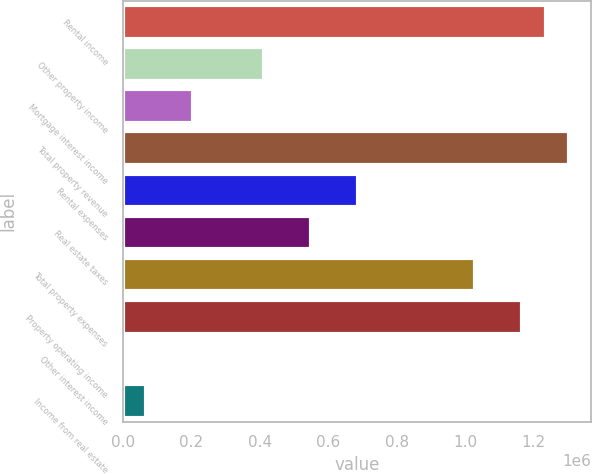Convert chart to OTSL. <chart><loc_0><loc_0><loc_500><loc_500><bar_chart><fcel>Rental income<fcel>Other property income<fcel>Mortgage interest income<fcel>Total property revenue<fcel>Rental expenses<fcel>Real estate taxes<fcel>Total property expenses<fcel>Property operating income<fcel>Other interest income<fcel>Income from real estate<nl><fcel>1.23489e+06<fcel>411692<fcel>205893<fcel>1.30349e+06<fcel>686090<fcel>548891<fcel>1.02909e+06<fcel>1.16629e+06<fcel>94<fcel>68693.6<nl></chart> 